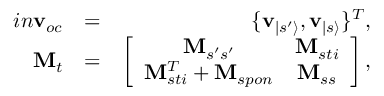<formula> <loc_0><loc_0><loc_500><loc_500>\begin{array} { r l r } { i n v _ { o c } } & { = } & { \{ v _ { | s ^ { \prime } \rangle } , v _ { | s \rangle } \} ^ { T } , } \\ { M _ { t } } & { = } & { \left [ \begin{array} { c c } { M _ { s ^ { \prime } s ^ { \prime } } } & { M _ { s t i } } \\ { M _ { s t i } ^ { T } + M _ { s p o n } } & { M _ { s s } } \end{array} \right ] , } \end{array}</formula> 